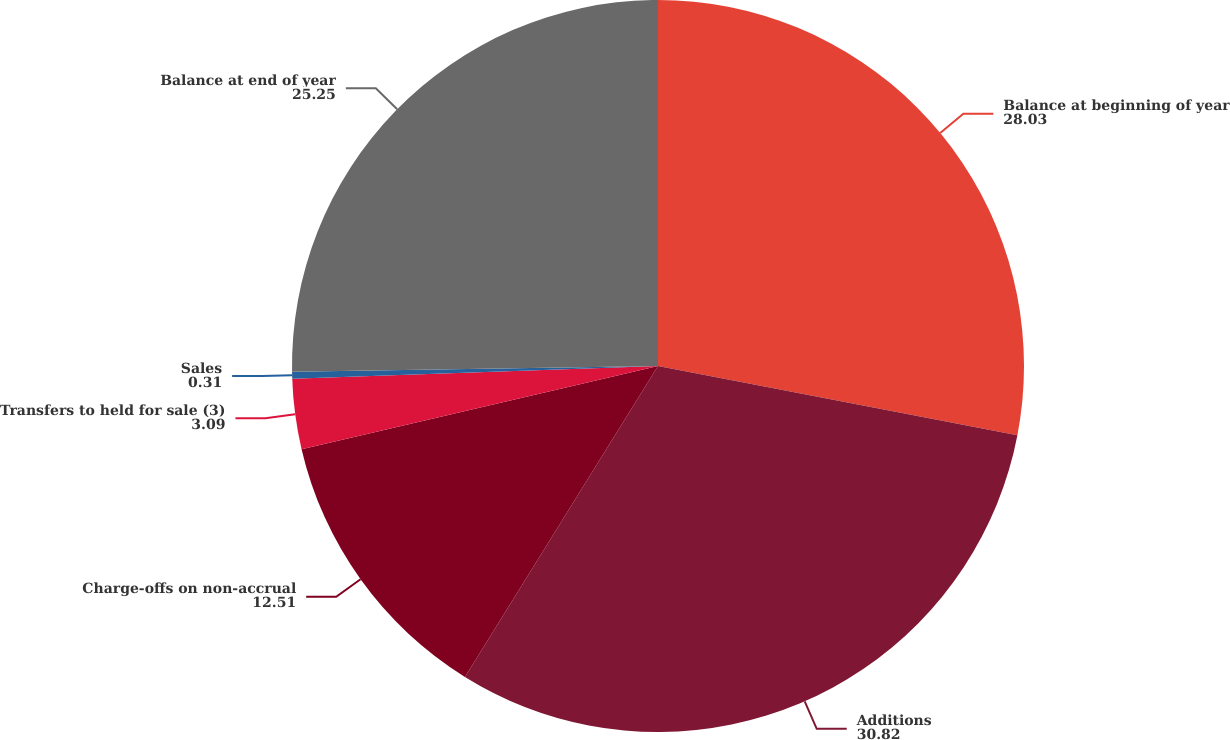Convert chart. <chart><loc_0><loc_0><loc_500><loc_500><pie_chart><fcel>Balance at beginning of year<fcel>Additions<fcel>Charge-offs on non-accrual<fcel>Transfers to held for sale (3)<fcel>Sales<fcel>Balance at end of year<nl><fcel>28.03%<fcel>30.82%<fcel>12.51%<fcel>3.09%<fcel>0.31%<fcel>25.25%<nl></chart> 